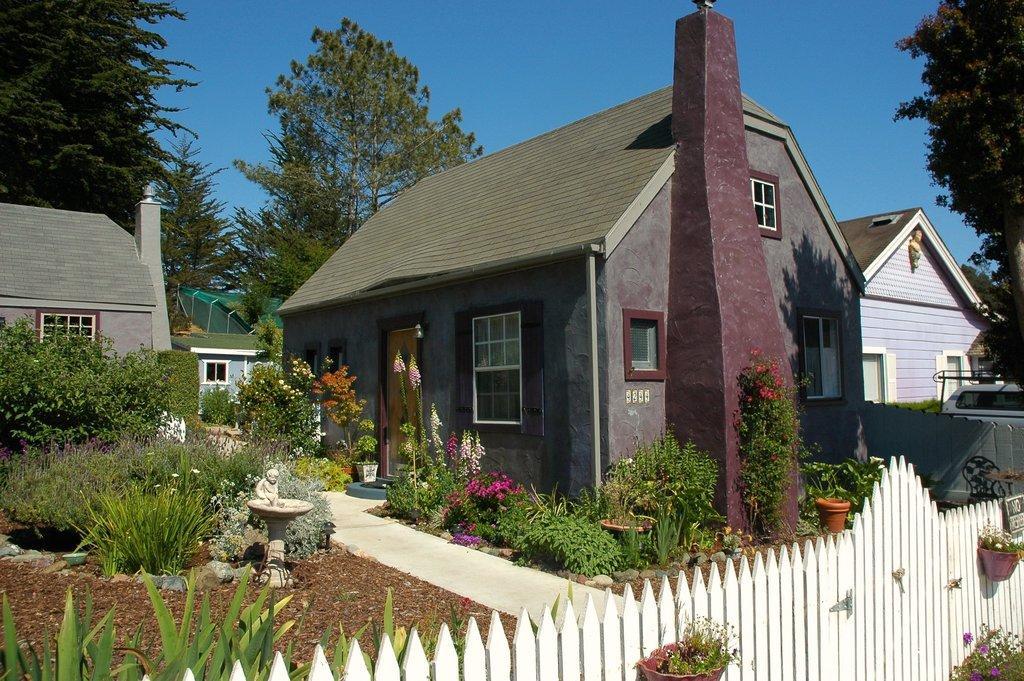Describe this image in one or two sentences. In this picture we can see plants, flowers, pots, picket fence and statue on the platform. We can see trees, houses, pillar and vehicle. In the background of the image we can see the sky. 